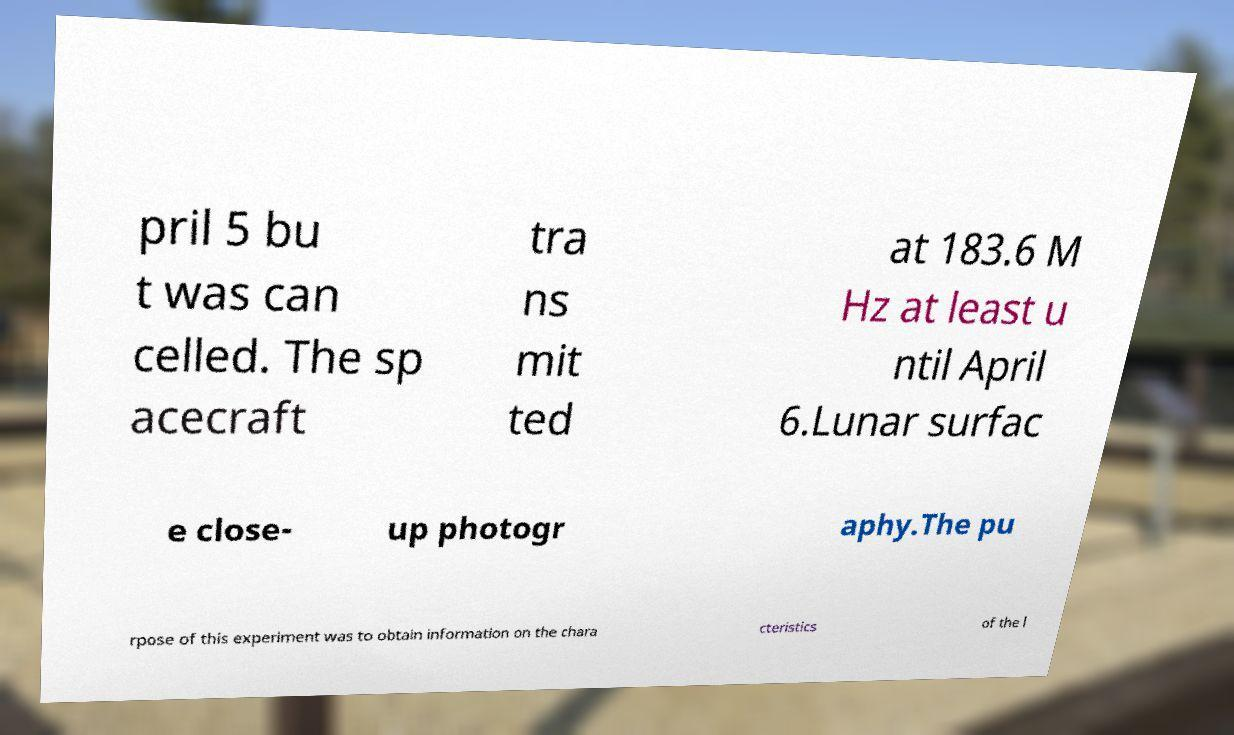Can you accurately transcribe the text from the provided image for me? pril 5 bu t was can celled. The sp acecraft tra ns mit ted at 183.6 M Hz at least u ntil April 6.Lunar surfac e close- up photogr aphy.The pu rpose of this experiment was to obtain information on the chara cteristics of the l 